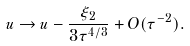Convert formula to latex. <formula><loc_0><loc_0><loc_500><loc_500>u \to u - \frac { \xi _ { 2 } } { 3 \tau ^ { 4 / 3 } } + O ( \tau ^ { - 2 } ) .</formula> 